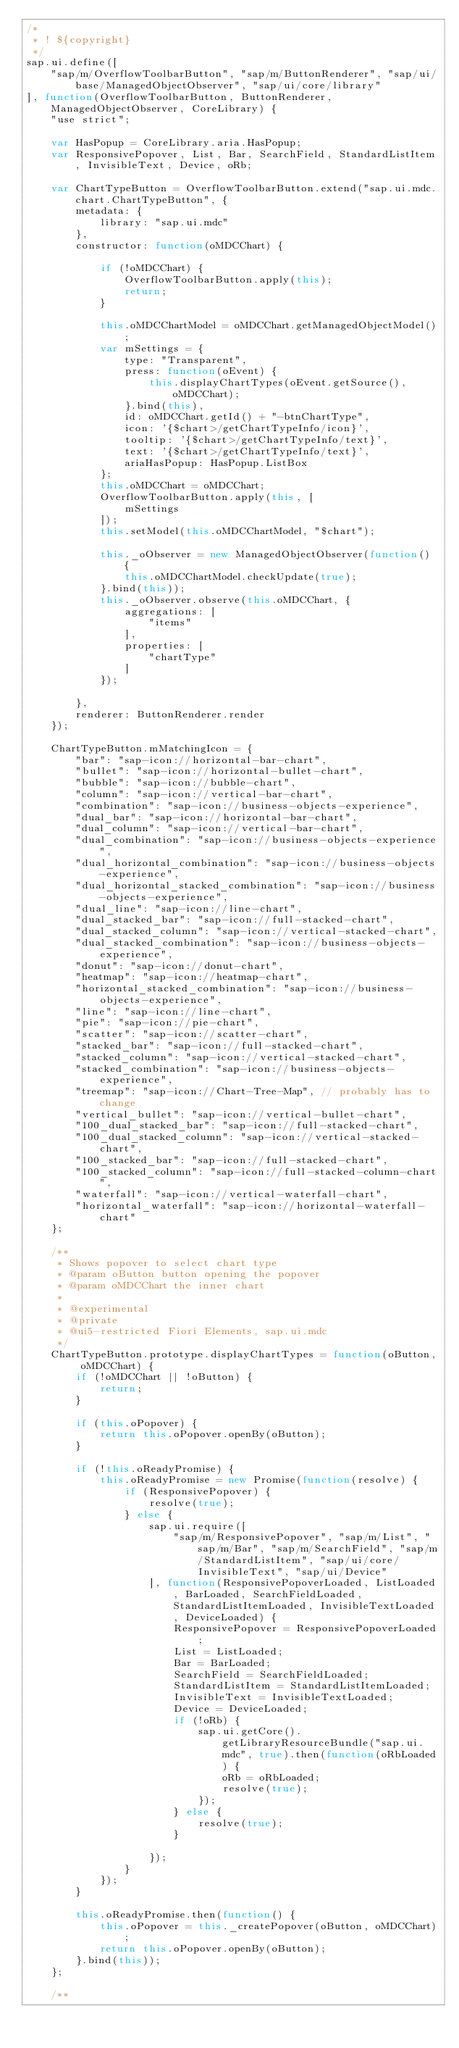Convert code to text. <code><loc_0><loc_0><loc_500><loc_500><_JavaScript_>/*
 * ! ${copyright}
 */
sap.ui.define([
	"sap/m/OverflowToolbarButton", "sap/m/ButtonRenderer", "sap/ui/base/ManagedObjectObserver", "sap/ui/core/library"
], function(OverflowToolbarButton, ButtonRenderer, ManagedObjectObserver, CoreLibrary) {
	"use strict";

	var HasPopup = CoreLibrary.aria.HasPopup;
	var ResponsivePopover, List, Bar, SearchField, StandardListItem, InvisibleText, Device, oRb;

	var ChartTypeButton = OverflowToolbarButton.extend("sap.ui.mdc.chart.ChartTypeButton", {
		metadata: {
			library: "sap.ui.mdc"
		},
		constructor: function(oMDCChart) {

			if (!oMDCChart) {
				OverflowToolbarButton.apply(this);
				return;
			}

			this.oMDCChartModel = oMDCChart.getManagedObjectModel();
			var mSettings = {
				type: "Transparent",
				press: function(oEvent) {
					this.displayChartTypes(oEvent.getSource(), oMDCChart);
				}.bind(this),
				id: oMDCChart.getId() + "-btnChartType",
				icon: '{$chart>/getChartTypeInfo/icon}',
				tooltip: '{$chart>/getChartTypeInfo/text}',
				text: '{$chart>/getChartTypeInfo/text}',
				ariaHasPopup: HasPopup.ListBox
			};
			this.oMDCChart = oMDCChart;
			OverflowToolbarButton.apply(this, [
				mSettings
			]);
			this.setModel(this.oMDCChartModel, "$chart");

			this._oObserver = new ManagedObjectObserver(function() {
				this.oMDCChartModel.checkUpdate(true);
			}.bind(this));
			this._oObserver.observe(this.oMDCChart, {
				aggregations: [
					"items"
				],
				properties: [
					"chartType"
				]
			});

		},
		renderer: ButtonRenderer.render
	});

	ChartTypeButton.mMatchingIcon = {
		"bar": "sap-icon://horizontal-bar-chart",
		"bullet": "sap-icon://horizontal-bullet-chart",
		"bubble": "sap-icon://bubble-chart",
		"column": "sap-icon://vertical-bar-chart",
		"combination": "sap-icon://business-objects-experience",
		"dual_bar": "sap-icon://horizontal-bar-chart",
		"dual_column": "sap-icon://vertical-bar-chart",
		"dual_combination": "sap-icon://business-objects-experience",
		"dual_horizontal_combination": "sap-icon://business-objects-experience",
		"dual_horizontal_stacked_combination": "sap-icon://business-objects-experience",
		"dual_line": "sap-icon://line-chart",
		"dual_stacked_bar": "sap-icon://full-stacked-chart",
		"dual_stacked_column": "sap-icon://vertical-stacked-chart",
		"dual_stacked_combination": "sap-icon://business-objects-experience",
		"donut": "sap-icon://donut-chart",
		"heatmap": "sap-icon://heatmap-chart",
		"horizontal_stacked_combination": "sap-icon://business-objects-experience",
		"line": "sap-icon://line-chart",
		"pie": "sap-icon://pie-chart",
		"scatter": "sap-icon://scatter-chart",
		"stacked_bar": "sap-icon://full-stacked-chart",
		"stacked_column": "sap-icon://vertical-stacked-chart",
		"stacked_combination": "sap-icon://business-objects-experience",
		"treemap": "sap-icon://Chart-Tree-Map", // probably has to change
		"vertical_bullet": "sap-icon://vertical-bullet-chart",
		"100_dual_stacked_bar": "sap-icon://full-stacked-chart",
		"100_dual_stacked_column": "sap-icon://vertical-stacked-chart",
		"100_stacked_bar": "sap-icon://full-stacked-chart",
		"100_stacked_column": "sap-icon://full-stacked-column-chart",
		"waterfall": "sap-icon://vertical-waterfall-chart",
		"horizontal_waterfall": "sap-icon://horizontal-waterfall-chart"
	};

	/**
	 * Shows popover to select chart type
	 * @param oButton button opening the popover
	 * @param oMDCChart the inner chart
	 *
	 * @experimental
	 * @private
	 * @ui5-restricted Fiori Elements, sap.ui.mdc
	 */
	ChartTypeButton.prototype.displayChartTypes = function(oButton, oMDCChart) {
		if (!oMDCChart || !oButton) {
			return;
		}

		if (this.oPopover) {
			return this.oPopover.openBy(oButton);
		}

		if (!this.oReadyPromise) {
			this.oReadyPromise = new Promise(function(resolve) {
				if (ResponsivePopover) {
					resolve(true);
				} else {
					sap.ui.require([
						"sap/m/ResponsivePopover", "sap/m/List", "sap/m/Bar", "sap/m/SearchField", "sap/m/StandardListItem", "sap/ui/core/InvisibleText", "sap/ui/Device"
					], function(ResponsivePopoverLoaded, ListLoaded, BarLoaded, SearchFieldLoaded, StandardListItemLoaded, InvisibleTextLoaded, DeviceLoaded) {
						ResponsivePopover = ResponsivePopoverLoaded;
						List = ListLoaded;
						Bar = BarLoaded;
						SearchField = SearchFieldLoaded;
						StandardListItem = StandardListItemLoaded;
						InvisibleText = InvisibleTextLoaded;
						Device = DeviceLoaded;
						if (!oRb) {
							sap.ui.getCore().getLibraryResourceBundle("sap.ui.mdc", true).then(function(oRbLoaded) {
								oRb = oRbLoaded;
								resolve(true);
							});
						} else {
							resolve(true);
						}

					});
				}
			});
		}

		this.oReadyPromise.then(function() {
			this.oPopover = this._createPopover(oButton, oMDCChart);
			return this.oPopover.openBy(oButton);
		}.bind(this));
	};

	/**</code> 